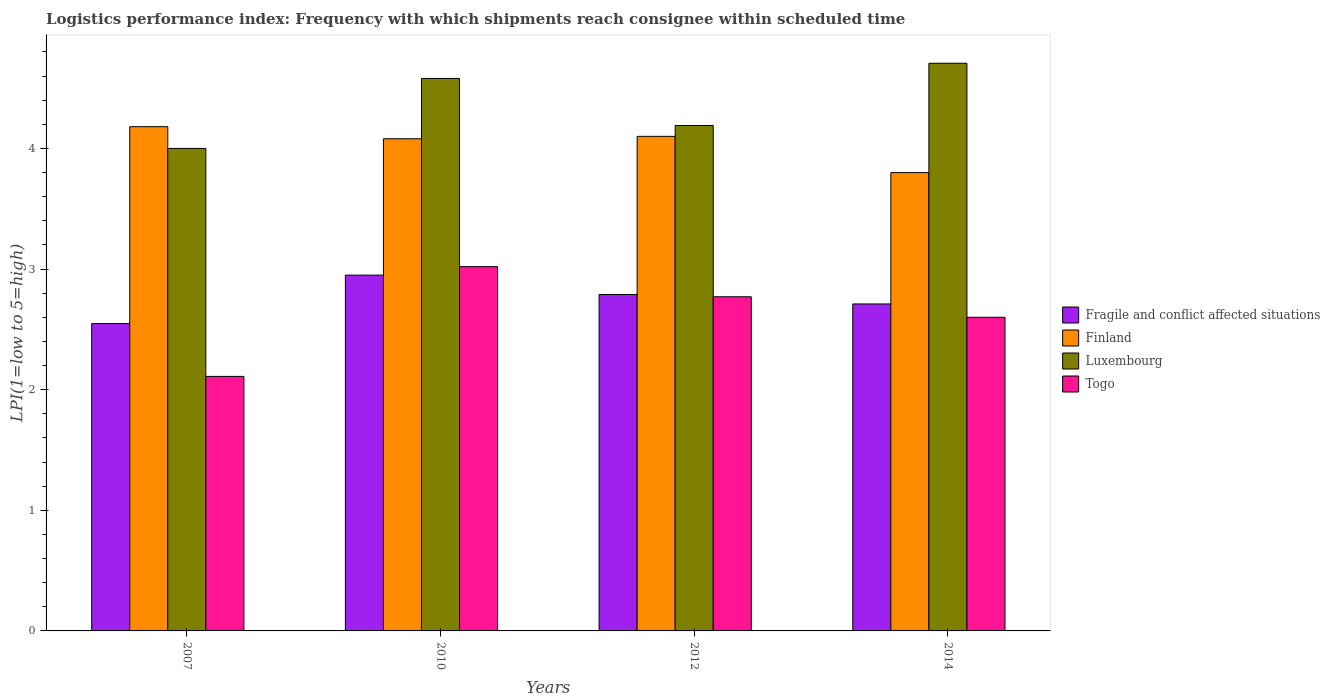Are the number of bars per tick equal to the number of legend labels?
Keep it short and to the point. Yes. Are the number of bars on each tick of the X-axis equal?
Keep it short and to the point. Yes. How many bars are there on the 2nd tick from the right?
Give a very brief answer. 4. What is the logistics performance index in Togo in 2007?
Provide a succinct answer. 2.11. Across all years, what is the maximum logistics performance index in Fragile and conflict affected situations?
Make the answer very short. 2.95. Across all years, what is the minimum logistics performance index in Finland?
Your answer should be very brief. 3.8. What is the total logistics performance index in Finland in the graph?
Your answer should be compact. 16.16. What is the difference between the logistics performance index in Togo in 2010 and that in 2014?
Keep it short and to the point. 0.42. What is the difference between the logistics performance index in Togo in 2010 and the logistics performance index in Luxembourg in 2014?
Provide a succinct answer. -1.69. What is the average logistics performance index in Luxembourg per year?
Provide a succinct answer. 4.37. In the year 2010, what is the difference between the logistics performance index in Togo and logistics performance index in Finland?
Ensure brevity in your answer.  -1.06. In how many years, is the logistics performance index in Finland greater than 1.6?
Make the answer very short. 4. What is the ratio of the logistics performance index in Togo in 2007 to that in 2012?
Give a very brief answer. 0.76. Is the logistics performance index in Luxembourg in 2007 less than that in 2014?
Keep it short and to the point. Yes. Is the difference between the logistics performance index in Togo in 2007 and 2010 greater than the difference between the logistics performance index in Finland in 2007 and 2010?
Provide a short and direct response. No. What is the difference between the highest and the second highest logistics performance index in Luxembourg?
Ensure brevity in your answer.  0.13. What is the difference between the highest and the lowest logistics performance index in Luxembourg?
Your response must be concise. 0.71. In how many years, is the logistics performance index in Fragile and conflict affected situations greater than the average logistics performance index in Fragile and conflict affected situations taken over all years?
Make the answer very short. 2. Is the sum of the logistics performance index in Luxembourg in 2007 and 2012 greater than the maximum logistics performance index in Togo across all years?
Ensure brevity in your answer.  Yes. Is it the case that in every year, the sum of the logistics performance index in Finland and logistics performance index in Fragile and conflict affected situations is greater than the sum of logistics performance index in Luxembourg and logistics performance index in Togo?
Offer a very short reply. No. What does the 3rd bar from the left in 2012 represents?
Your response must be concise. Luxembourg. What does the 4th bar from the right in 2010 represents?
Your answer should be very brief. Fragile and conflict affected situations. How many bars are there?
Provide a short and direct response. 16. Does the graph contain any zero values?
Offer a very short reply. No. How many legend labels are there?
Provide a succinct answer. 4. How are the legend labels stacked?
Make the answer very short. Vertical. What is the title of the graph?
Keep it short and to the point. Logistics performance index: Frequency with which shipments reach consignee within scheduled time. What is the label or title of the Y-axis?
Offer a terse response. LPI(1=low to 5=high). What is the LPI(1=low to 5=high) in Fragile and conflict affected situations in 2007?
Your answer should be very brief. 2.55. What is the LPI(1=low to 5=high) of Finland in 2007?
Keep it short and to the point. 4.18. What is the LPI(1=low to 5=high) in Togo in 2007?
Give a very brief answer. 2.11. What is the LPI(1=low to 5=high) in Fragile and conflict affected situations in 2010?
Offer a very short reply. 2.95. What is the LPI(1=low to 5=high) of Finland in 2010?
Offer a very short reply. 4.08. What is the LPI(1=low to 5=high) of Luxembourg in 2010?
Provide a succinct answer. 4.58. What is the LPI(1=low to 5=high) in Togo in 2010?
Your answer should be compact. 3.02. What is the LPI(1=low to 5=high) in Fragile and conflict affected situations in 2012?
Make the answer very short. 2.79. What is the LPI(1=low to 5=high) of Finland in 2012?
Offer a very short reply. 4.1. What is the LPI(1=low to 5=high) in Luxembourg in 2012?
Your response must be concise. 4.19. What is the LPI(1=low to 5=high) of Togo in 2012?
Keep it short and to the point. 2.77. What is the LPI(1=low to 5=high) in Fragile and conflict affected situations in 2014?
Ensure brevity in your answer.  2.71. What is the LPI(1=low to 5=high) of Finland in 2014?
Provide a short and direct response. 3.8. What is the LPI(1=low to 5=high) in Luxembourg in 2014?
Make the answer very short. 4.71. What is the LPI(1=low to 5=high) in Togo in 2014?
Provide a short and direct response. 2.6. Across all years, what is the maximum LPI(1=low to 5=high) of Fragile and conflict affected situations?
Provide a short and direct response. 2.95. Across all years, what is the maximum LPI(1=low to 5=high) in Finland?
Your response must be concise. 4.18. Across all years, what is the maximum LPI(1=low to 5=high) in Luxembourg?
Give a very brief answer. 4.71. Across all years, what is the maximum LPI(1=low to 5=high) of Togo?
Provide a short and direct response. 3.02. Across all years, what is the minimum LPI(1=low to 5=high) in Fragile and conflict affected situations?
Provide a short and direct response. 2.55. Across all years, what is the minimum LPI(1=low to 5=high) in Finland?
Offer a terse response. 3.8. Across all years, what is the minimum LPI(1=low to 5=high) in Togo?
Provide a short and direct response. 2.11. What is the total LPI(1=low to 5=high) in Fragile and conflict affected situations in the graph?
Make the answer very short. 11. What is the total LPI(1=low to 5=high) in Finland in the graph?
Your response must be concise. 16.16. What is the total LPI(1=low to 5=high) of Luxembourg in the graph?
Your answer should be very brief. 17.48. What is the total LPI(1=low to 5=high) of Togo in the graph?
Provide a short and direct response. 10.5. What is the difference between the LPI(1=low to 5=high) in Fragile and conflict affected situations in 2007 and that in 2010?
Ensure brevity in your answer.  -0.4. What is the difference between the LPI(1=low to 5=high) of Finland in 2007 and that in 2010?
Give a very brief answer. 0.1. What is the difference between the LPI(1=low to 5=high) of Luxembourg in 2007 and that in 2010?
Your answer should be very brief. -0.58. What is the difference between the LPI(1=low to 5=high) in Togo in 2007 and that in 2010?
Keep it short and to the point. -0.91. What is the difference between the LPI(1=low to 5=high) of Fragile and conflict affected situations in 2007 and that in 2012?
Offer a very short reply. -0.24. What is the difference between the LPI(1=low to 5=high) in Finland in 2007 and that in 2012?
Ensure brevity in your answer.  0.08. What is the difference between the LPI(1=low to 5=high) of Luxembourg in 2007 and that in 2012?
Provide a succinct answer. -0.19. What is the difference between the LPI(1=low to 5=high) of Togo in 2007 and that in 2012?
Ensure brevity in your answer.  -0.66. What is the difference between the LPI(1=low to 5=high) in Fragile and conflict affected situations in 2007 and that in 2014?
Keep it short and to the point. -0.16. What is the difference between the LPI(1=low to 5=high) of Finland in 2007 and that in 2014?
Ensure brevity in your answer.  0.38. What is the difference between the LPI(1=low to 5=high) in Luxembourg in 2007 and that in 2014?
Give a very brief answer. -0.71. What is the difference between the LPI(1=low to 5=high) in Togo in 2007 and that in 2014?
Your response must be concise. -0.49. What is the difference between the LPI(1=low to 5=high) in Fragile and conflict affected situations in 2010 and that in 2012?
Ensure brevity in your answer.  0.16. What is the difference between the LPI(1=low to 5=high) of Finland in 2010 and that in 2012?
Provide a succinct answer. -0.02. What is the difference between the LPI(1=low to 5=high) in Luxembourg in 2010 and that in 2012?
Offer a very short reply. 0.39. What is the difference between the LPI(1=low to 5=high) of Togo in 2010 and that in 2012?
Provide a succinct answer. 0.25. What is the difference between the LPI(1=low to 5=high) of Fragile and conflict affected situations in 2010 and that in 2014?
Give a very brief answer. 0.24. What is the difference between the LPI(1=low to 5=high) of Finland in 2010 and that in 2014?
Offer a terse response. 0.28. What is the difference between the LPI(1=low to 5=high) of Luxembourg in 2010 and that in 2014?
Ensure brevity in your answer.  -0.13. What is the difference between the LPI(1=low to 5=high) in Togo in 2010 and that in 2014?
Your answer should be compact. 0.42. What is the difference between the LPI(1=low to 5=high) of Fragile and conflict affected situations in 2012 and that in 2014?
Keep it short and to the point. 0.08. What is the difference between the LPI(1=low to 5=high) in Finland in 2012 and that in 2014?
Offer a very short reply. 0.3. What is the difference between the LPI(1=low to 5=high) in Luxembourg in 2012 and that in 2014?
Offer a terse response. -0.52. What is the difference between the LPI(1=low to 5=high) in Togo in 2012 and that in 2014?
Offer a very short reply. 0.17. What is the difference between the LPI(1=low to 5=high) in Fragile and conflict affected situations in 2007 and the LPI(1=low to 5=high) in Finland in 2010?
Keep it short and to the point. -1.53. What is the difference between the LPI(1=low to 5=high) in Fragile and conflict affected situations in 2007 and the LPI(1=low to 5=high) in Luxembourg in 2010?
Offer a terse response. -2.03. What is the difference between the LPI(1=low to 5=high) in Fragile and conflict affected situations in 2007 and the LPI(1=low to 5=high) in Togo in 2010?
Ensure brevity in your answer.  -0.47. What is the difference between the LPI(1=low to 5=high) of Finland in 2007 and the LPI(1=low to 5=high) of Luxembourg in 2010?
Ensure brevity in your answer.  -0.4. What is the difference between the LPI(1=low to 5=high) of Finland in 2007 and the LPI(1=low to 5=high) of Togo in 2010?
Your answer should be compact. 1.16. What is the difference between the LPI(1=low to 5=high) in Luxembourg in 2007 and the LPI(1=low to 5=high) in Togo in 2010?
Ensure brevity in your answer.  0.98. What is the difference between the LPI(1=low to 5=high) in Fragile and conflict affected situations in 2007 and the LPI(1=low to 5=high) in Finland in 2012?
Your response must be concise. -1.55. What is the difference between the LPI(1=low to 5=high) of Fragile and conflict affected situations in 2007 and the LPI(1=low to 5=high) of Luxembourg in 2012?
Make the answer very short. -1.64. What is the difference between the LPI(1=low to 5=high) of Fragile and conflict affected situations in 2007 and the LPI(1=low to 5=high) of Togo in 2012?
Give a very brief answer. -0.22. What is the difference between the LPI(1=low to 5=high) of Finland in 2007 and the LPI(1=low to 5=high) of Luxembourg in 2012?
Provide a succinct answer. -0.01. What is the difference between the LPI(1=low to 5=high) in Finland in 2007 and the LPI(1=low to 5=high) in Togo in 2012?
Make the answer very short. 1.41. What is the difference between the LPI(1=low to 5=high) in Luxembourg in 2007 and the LPI(1=low to 5=high) in Togo in 2012?
Provide a succinct answer. 1.23. What is the difference between the LPI(1=low to 5=high) in Fragile and conflict affected situations in 2007 and the LPI(1=low to 5=high) in Finland in 2014?
Make the answer very short. -1.25. What is the difference between the LPI(1=low to 5=high) in Fragile and conflict affected situations in 2007 and the LPI(1=low to 5=high) in Luxembourg in 2014?
Keep it short and to the point. -2.16. What is the difference between the LPI(1=low to 5=high) of Fragile and conflict affected situations in 2007 and the LPI(1=low to 5=high) of Togo in 2014?
Ensure brevity in your answer.  -0.05. What is the difference between the LPI(1=low to 5=high) of Finland in 2007 and the LPI(1=low to 5=high) of Luxembourg in 2014?
Offer a very short reply. -0.53. What is the difference between the LPI(1=low to 5=high) in Finland in 2007 and the LPI(1=low to 5=high) in Togo in 2014?
Provide a short and direct response. 1.58. What is the difference between the LPI(1=low to 5=high) of Fragile and conflict affected situations in 2010 and the LPI(1=low to 5=high) of Finland in 2012?
Your answer should be compact. -1.15. What is the difference between the LPI(1=low to 5=high) in Fragile and conflict affected situations in 2010 and the LPI(1=low to 5=high) in Luxembourg in 2012?
Provide a short and direct response. -1.24. What is the difference between the LPI(1=low to 5=high) in Fragile and conflict affected situations in 2010 and the LPI(1=low to 5=high) in Togo in 2012?
Your answer should be compact. 0.18. What is the difference between the LPI(1=low to 5=high) in Finland in 2010 and the LPI(1=low to 5=high) in Luxembourg in 2012?
Offer a very short reply. -0.11. What is the difference between the LPI(1=low to 5=high) in Finland in 2010 and the LPI(1=low to 5=high) in Togo in 2012?
Offer a terse response. 1.31. What is the difference between the LPI(1=low to 5=high) of Luxembourg in 2010 and the LPI(1=low to 5=high) of Togo in 2012?
Provide a short and direct response. 1.81. What is the difference between the LPI(1=low to 5=high) in Fragile and conflict affected situations in 2010 and the LPI(1=low to 5=high) in Finland in 2014?
Give a very brief answer. -0.85. What is the difference between the LPI(1=low to 5=high) in Fragile and conflict affected situations in 2010 and the LPI(1=low to 5=high) in Luxembourg in 2014?
Provide a short and direct response. -1.76. What is the difference between the LPI(1=low to 5=high) of Fragile and conflict affected situations in 2010 and the LPI(1=low to 5=high) of Togo in 2014?
Your answer should be very brief. 0.35. What is the difference between the LPI(1=low to 5=high) of Finland in 2010 and the LPI(1=low to 5=high) of Luxembourg in 2014?
Provide a short and direct response. -0.63. What is the difference between the LPI(1=low to 5=high) of Finland in 2010 and the LPI(1=low to 5=high) of Togo in 2014?
Offer a very short reply. 1.48. What is the difference between the LPI(1=low to 5=high) in Luxembourg in 2010 and the LPI(1=low to 5=high) in Togo in 2014?
Make the answer very short. 1.98. What is the difference between the LPI(1=low to 5=high) of Fragile and conflict affected situations in 2012 and the LPI(1=low to 5=high) of Finland in 2014?
Provide a succinct answer. -1.01. What is the difference between the LPI(1=low to 5=high) of Fragile and conflict affected situations in 2012 and the LPI(1=low to 5=high) of Luxembourg in 2014?
Provide a short and direct response. -1.92. What is the difference between the LPI(1=low to 5=high) of Fragile and conflict affected situations in 2012 and the LPI(1=low to 5=high) of Togo in 2014?
Give a very brief answer. 0.19. What is the difference between the LPI(1=low to 5=high) in Finland in 2012 and the LPI(1=low to 5=high) in Luxembourg in 2014?
Ensure brevity in your answer.  -0.61. What is the difference between the LPI(1=low to 5=high) in Finland in 2012 and the LPI(1=low to 5=high) in Togo in 2014?
Make the answer very short. 1.5. What is the difference between the LPI(1=low to 5=high) of Luxembourg in 2012 and the LPI(1=low to 5=high) of Togo in 2014?
Provide a succinct answer. 1.59. What is the average LPI(1=low to 5=high) in Fragile and conflict affected situations per year?
Ensure brevity in your answer.  2.75. What is the average LPI(1=low to 5=high) of Finland per year?
Provide a succinct answer. 4.04. What is the average LPI(1=low to 5=high) in Luxembourg per year?
Offer a very short reply. 4.37. What is the average LPI(1=low to 5=high) of Togo per year?
Give a very brief answer. 2.62. In the year 2007, what is the difference between the LPI(1=low to 5=high) of Fragile and conflict affected situations and LPI(1=low to 5=high) of Finland?
Ensure brevity in your answer.  -1.63. In the year 2007, what is the difference between the LPI(1=low to 5=high) in Fragile and conflict affected situations and LPI(1=low to 5=high) in Luxembourg?
Offer a terse response. -1.45. In the year 2007, what is the difference between the LPI(1=low to 5=high) of Fragile and conflict affected situations and LPI(1=low to 5=high) of Togo?
Make the answer very short. 0.44. In the year 2007, what is the difference between the LPI(1=low to 5=high) in Finland and LPI(1=low to 5=high) in Luxembourg?
Give a very brief answer. 0.18. In the year 2007, what is the difference between the LPI(1=low to 5=high) in Finland and LPI(1=low to 5=high) in Togo?
Your answer should be very brief. 2.07. In the year 2007, what is the difference between the LPI(1=low to 5=high) of Luxembourg and LPI(1=low to 5=high) of Togo?
Make the answer very short. 1.89. In the year 2010, what is the difference between the LPI(1=low to 5=high) in Fragile and conflict affected situations and LPI(1=low to 5=high) in Finland?
Offer a very short reply. -1.13. In the year 2010, what is the difference between the LPI(1=low to 5=high) of Fragile and conflict affected situations and LPI(1=low to 5=high) of Luxembourg?
Give a very brief answer. -1.63. In the year 2010, what is the difference between the LPI(1=low to 5=high) in Fragile and conflict affected situations and LPI(1=low to 5=high) in Togo?
Your response must be concise. -0.07. In the year 2010, what is the difference between the LPI(1=low to 5=high) of Finland and LPI(1=low to 5=high) of Luxembourg?
Ensure brevity in your answer.  -0.5. In the year 2010, what is the difference between the LPI(1=low to 5=high) of Finland and LPI(1=low to 5=high) of Togo?
Your response must be concise. 1.06. In the year 2010, what is the difference between the LPI(1=low to 5=high) in Luxembourg and LPI(1=low to 5=high) in Togo?
Provide a succinct answer. 1.56. In the year 2012, what is the difference between the LPI(1=low to 5=high) of Fragile and conflict affected situations and LPI(1=low to 5=high) of Finland?
Keep it short and to the point. -1.31. In the year 2012, what is the difference between the LPI(1=low to 5=high) of Fragile and conflict affected situations and LPI(1=low to 5=high) of Luxembourg?
Your answer should be compact. -1.4. In the year 2012, what is the difference between the LPI(1=low to 5=high) of Fragile and conflict affected situations and LPI(1=low to 5=high) of Togo?
Ensure brevity in your answer.  0.02. In the year 2012, what is the difference between the LPI(1=low to 5=high) of Finland and LPI(1=low to 5=high) of Luxembourg?
Ensure brevity in your answer.  -0.09. In the year 2012, what is the difference between the LPI(1=low to 5=high) in Finland and LPI(1=low to 5=high) in Togo?
Offer a very short reply. 1.33. In the year 2012, what is the difference between the LPI(1=low to 5=high) in Luxembourg and LPI(1=low to 5=high) in Togo?
Keep it short and to the point. 1.42. In the year 2014, what is the difference between the LPI(1=low to 5=high) in Fragile and conflict affected situations and LPI(1=low to 5=high) in Finland?
Ensure brevity in your answer.  -1.09. In the year 2014, what is the difference between the LPI(1=low to 5=high) of Fragile and conflict affected situations and LPI(1=low to 5=high) of Luxembourg?
Your response must be concise. -2. In the year 2014, what is the difference between the LPI(1=low to 5=high) in Fragile and conflict affected situations and LPI(1=low to 5=high) in Togo?
Provide a short and direct response. 0.11. In the year 2014, what is the difference between the LPI(1=low to 5=high) in Finland and LPI(1=low to 5=high) in Luxembourg?
Your answer should be very brief. -0.91. In the year 2014, what is the difference between the LPI(1=low to 5=high) of Finland and LPI(1=low to 5=high) of Togo?
Your answer should be compact. 1.2. In the year 2014, what is the difference between the LPI(1=low to 5=high) of Luxembourg and LPI(1=low to 5=high) of Togo?
Your answer should be very brief. 2.11. What is the ratio of the LPI(1=low to 5=high) in Fragile and conflict affected situations in 2007 to that in 2010?
Provide a short and direct response. 0.86. What is the ratio of the LPI(1=low to 5=high) in Finland in 2007 to that in 2010?
Offer a very short reply. 1.02. What is the ratio of the LPI(1=low to 5=high) in Luxembourg in 2007 to that in 2010?
Make the answer very short. 0.87. What is the ratio of the LPI(1=low to 5=high) of Togo in 2007 to that in 2010?
Your answer should be compact. 0.7. What is the ratio of the LPI(1=low to 5=high) in Fragile and conflict affected situations in 2007 to that in 2012?
Provide a succinct answer. 0.91. What is the ratio of the LPI(1=low to 5=high) in Finland in 2007 to that in 2012?
Make the answer very short. 1.02. What is the ratio of the LPI(1=low to 5=high) in Luxembourg in 2007 to that in 2012?
Keep it short and to the point. 0.95. What is the ratio of the LPI(1=low to 5=high) of Togo in 2007 to that in 2012?
Make the answer very short. 0.76. What is the ratio of the LPI(1=low to 5=high) in Finland in 2007 to that in 2014?
Your response must be concise. 1.1. What is the ratio of the LPI(1=low to 5=high) of Togo in 2007 to that in 2014?
Your response must be concise. 0.81. What is the ratio of the LPI(1=low to 5=high) of Fragile and conflict affected situations in 2010 to that in 2012?
Your response must be concise. 1.06. What is the ratio of the LPI(1=low to 5=high) of Luxembourg in 2010 to that in 2012?
Your answer should be compact. 1.09. What is the ratio of the LPI(1=low to 5=high) of Togo in 2010 to that in 2012?
Make the answer very short. 1.09. What is the ratio of the LPI(1=low to 5=high) of Fragile and conflict affected situations in 2010 to that in 2014?
Provide a short and direct response. 1.09. What is the ratio of the LPI(1=low to 5=high) of Finland in 2010 to that in 2014?
Offer a very short reply. 1.07. What is the ratio of the LPI(1=low to 5=high) of Luxembourg in 2010 to that in 2014?
Provide a short and direct response. 0.97. What is the ratio of the LPI(1=low to 5=high) in Togo in 2010 to that in 2014?
Your answer should be compact. 1.16. What is the ratio of the LPI(1=low to 5=high) of Fragile and conflict affected situations in 2012 to that in 2014?
Provide a short and direct response. 1.03. What is the ratio of the LPI(1=low to 5=high) of Finland in 2012 to that in 2014?
Provide a short and direct response. 1.08. What is the ratio of the LPI(1=low to 5=high) in Luxembourg in 2012 to that in 2014?
Your answer should be compact. 0.89. What is the ratio of the LPI(1=low to 5=high) in Togo in 2012 to that in 2014?
Make the answer very short. 1.07. What is the difference between the highest and the second highest LPI(1=low to 5=high) in Fragile and conflict affected situations?
Offer a terse response. 0.16. What is the difference between the highest and the second highest LPI(1=low to 5=high) of Finland?
Offer a terse response. 0.08. What is the difference between the highest and the second highest LPI(1=low to 5=high) in Luxembourg?
Offer a terse response. 0.13. What is the difference between the highest and the lowest LPI(1=low to 5=high) of Fragile and conflict affected situations?
Provide a short and direct response. 0.4. What is the difference between the highest and the lowest LPI(1=low to 5=high) of Finland?
Make the answer very short. 0.38. What is the difference between the highest and the lowest LPI(1=low to 5=high) of Luxembourg?
Ensure brevity in your answer.  0.71. What is the difference between the highest and the lowest LPI(1=low to 5=high) of Togo?
Ensure brevity in your answer.  0.91. 